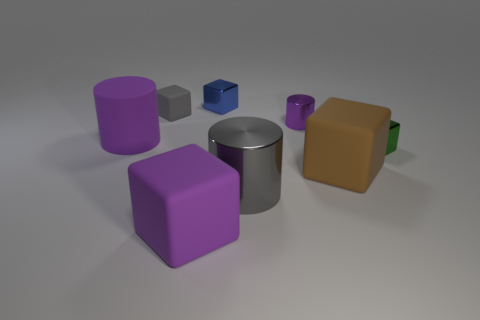There is a metal cylinder in front of the tiny purple metal cylinder; what is its size?
Provide a succinct answer. Large. There is a brown cube that is the same material as the tiny gray object; what size is it?
Give a very brief answer. Large. What number of big things are the same color as the tiny matte object?
Your answer should be very brief. 1. Are there any large shiny balls?
Keep it short and to the point. No. Do the small matte object and the tiny green thing that is right of the tiny purple metal cylinder have the same shape?
Offer a very short reply. Yes. There is a small metal block behind the purple object that is behind the cylinder on the left side of the tiny matte block; what color is it?
Offer a very short reply. Blue. There is a tiny purple shiny cylinder; are there any purple cylinders on the left side of it?
Your response must be concise. Yes. What size is the block that is the same color as the large shiny object?
Your response must be concise. Small. Is there another small purple cylinder that has the same material as the small purple cylinder?
Keep it short and to the point. No. What color is the small shiny cylinder?
Offer a terse response. Purple. 